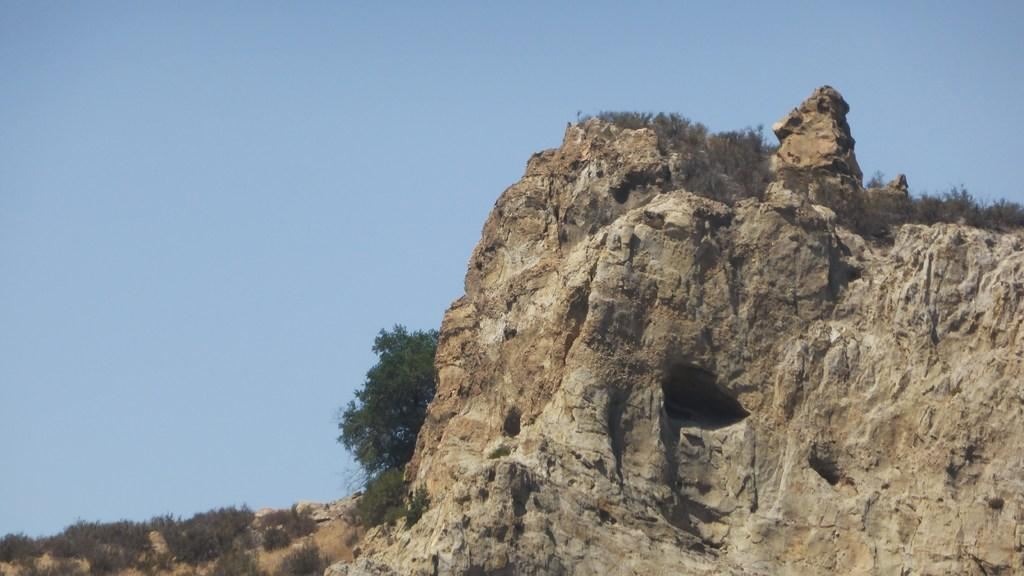What type of landform can be seen in the image? There is a hill in the image. What type of vegetation is present on the hill? There is grass and plants in the image. Can you describe the tree in the image? There is a tree in the image. What can be seen in the background of the image? The sky is visible in the background of the image. What type of cherry is growing on the tree in the image? There is no cherry present in the image; it is a tree without any specific fruit mentioned. 